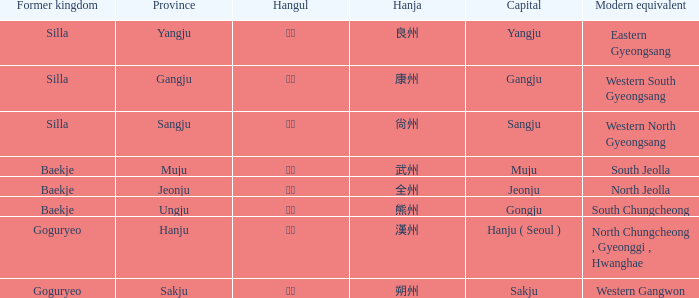Could you help me parse every detail presented in this table? {'header': ['Former kingdom', 'Province', 'Hangul', 'Hanja', 'Capital', 'Modern equivalent'], 'rows': [['Silla', 'Yangju', '양주', '良州', 'Yangju', 'Eastern Gyeongsang'], ['Silla', 'Gangju', '강주', '康州', 'Gangju', 'Western South Gyeongsang'], ['Silla', 'Sangju', '상주', '尙州', 'Sangju', 'Western North Gyeongsang'], ['Baekje', 'Muju', '무주', '武州', 'Muju', 'South Jeolla'], ['Baekje', 'Jeonju', '전주', '全州', 'Jeonju', 'North Jeolla'], ['Baekje', 'Ungju', '웅주', '熊州', 'Gongju', 'South Chungcheong'], ['Goguryeo', 'Hanju', '한주', '漢州', 'Hanju ( Seoul )', 'North Chungcheong , Gyeonggi , Hwanghae'], ['Goguryeo', 'Sakju', '삭주', '朔州', 'Sakju', 'Western Gangwon']]} What capital is represented by the hanja 尙州? Sangju. 